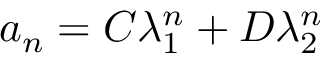Convert formula to latex. <formula><loc_0><loc_0><loc_500><loc_500>a _ { n } = C \lambda _ { 1 } ^ { n } + D \lambda _ { 2 } ^ { n }</formula> 